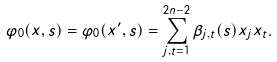<formula> <loc_0><loc_0><loc_500><loc_500>\varphi _ { 0 } ( x , s ) = \varphi _ { 0 } ( x ^ { \prime } , s ) = \sum ^ { 2 n - 2 } _ { j , t = 1 } \beta _ { j , t } ( s ) x _ { j } x _ { t } .</formula> 